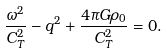Convert formula to latex. <formula><loc_0><loc_0><loc_500><loc_500>\frac { \omega ^ { 2 } } { C ^ { 2 } _ { T } } - q ^ { 2 } + \frac { 4 \pi G \rho _ { 0 } } { C ^ { 2 } _ { T } } = 0 .</formula> 